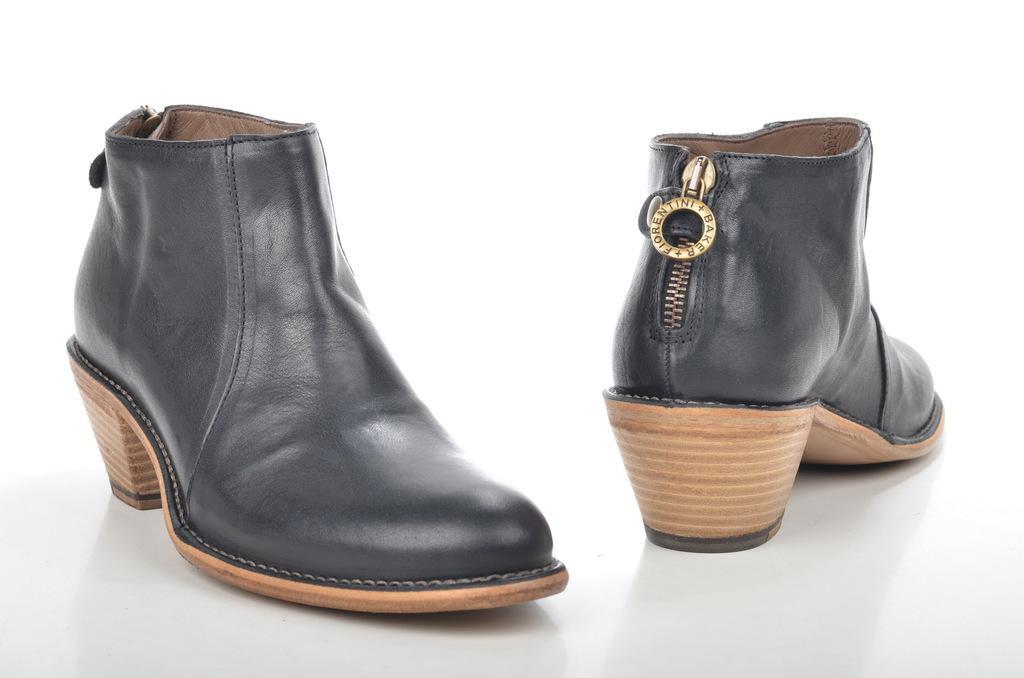Can you describe this image briefly? These are the 2 shoes which are in black color. 